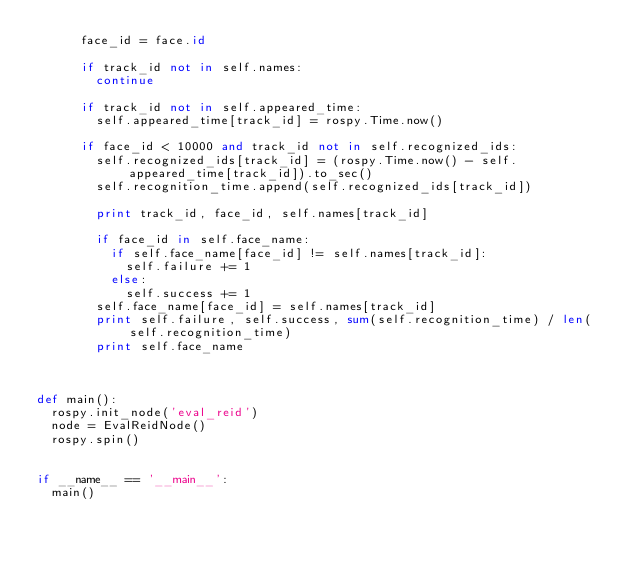Convert code to text. <code><loc_0><loc_0><loc_500><loc_500><_Python_>			face_id = face.id

			if track_id not in self.names:
				continue

			if track_id not in self.appeared_time:
				self.appeared_time[track_id] = rospy.Time.now()

			if face_id < 10000 and track_id not in self.recognized_ids:
				self.recognized_ids[track_id] = (rospy.Time.now() - self.appeared_time[track_id]).to_sec()
				self.recognition_time.append(self.recognized_ids[track_id])

				print track_id, face_id, self.names[track_id]

				if face_id in self.face_name:
					if self.face_name[face_id] != self.names[track_id]:
						self.failure += 1
					else:
						self.success += 1
				self.face_name[face_id] = self.names[track_id]
				print self.failure, self.success, sum(self.recognition_time) / len(self.recognition_time)
				print self.face_name



def main():
	rospy.init_node('eval_reid')
	node = EvalReidNode()
	rospy.spin()


if __name__ == '__main__':
	main()
</code> 